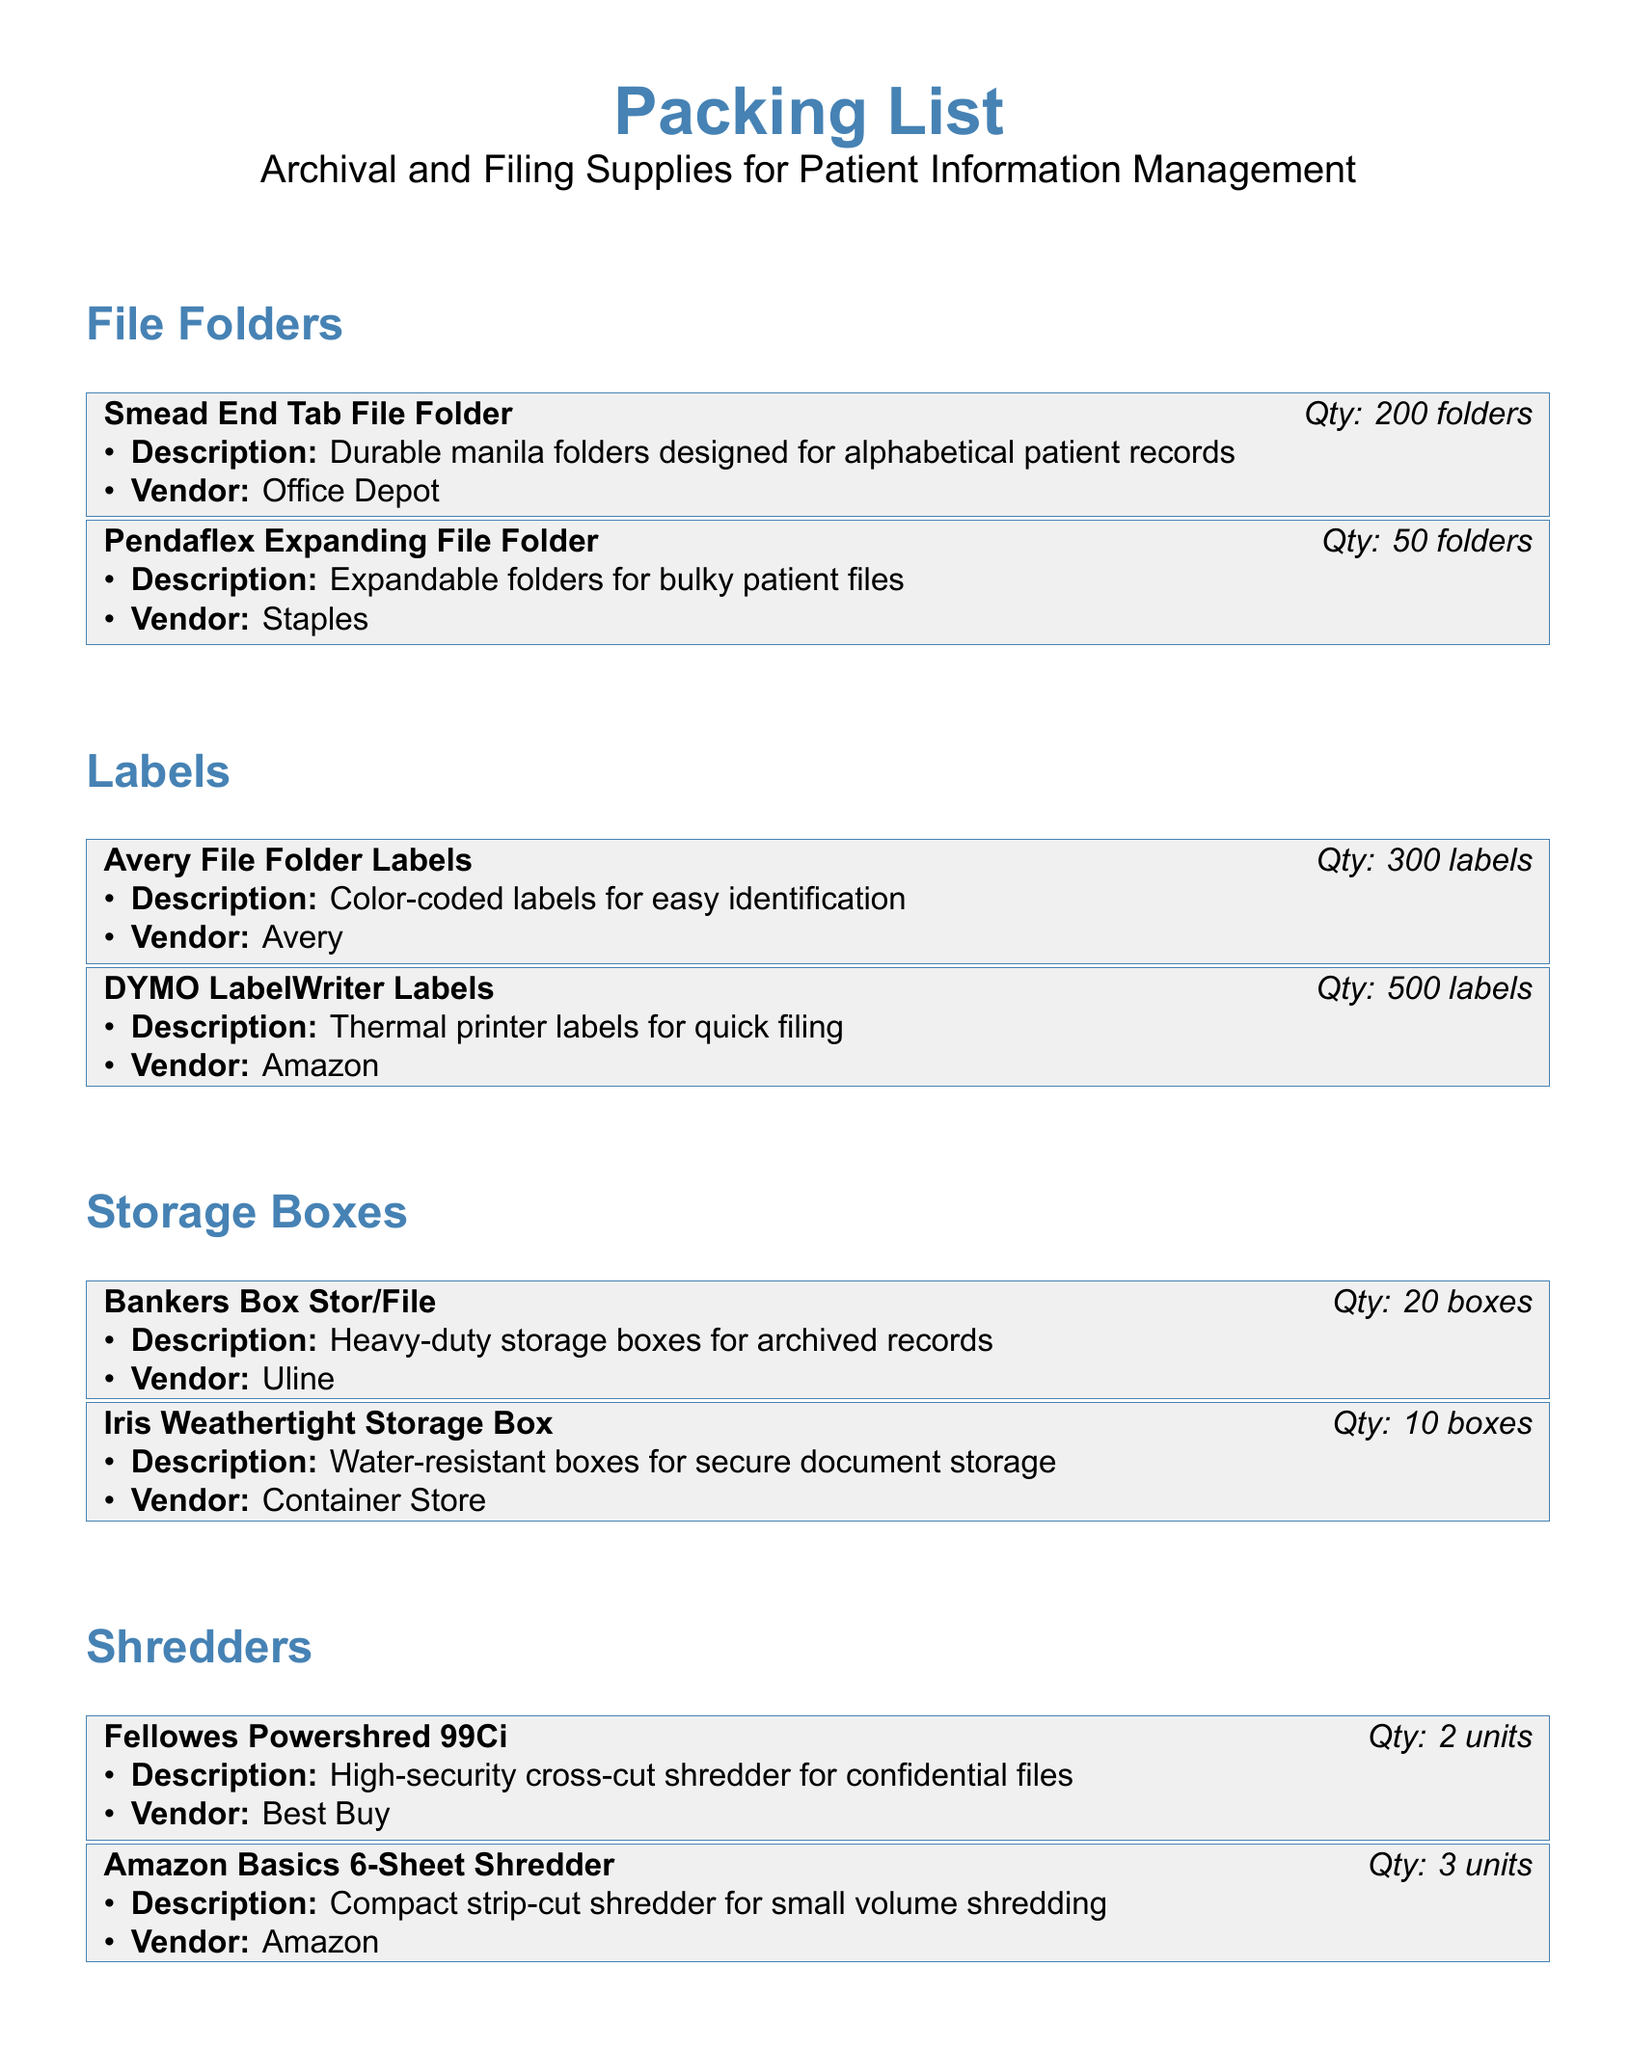What is the quantity of Smead End Tab File Folders? The document specifically lists that there are 200 folders of Smead End Tab File Folders.
Answer: 200 folders What type of shredder is the Fellowes Powershred 99Ci? The document describes this shredder as a high-security cross-cut shredder for confidential files.
Answer: High-security cross-cut How many boxes are included in the Bankers Box Stor/File? The inventory states that there are 20 boxes of Bankers Box Stor/File.
Answer: 20 boxes Which vendor supplies the Brother P-touch Label Maker? The document lists Brother as the vendor for the Brother P-touch Label Maker.
Answer: Brother What is the total number of labels provided by DYMO LabelWriter? The document mentions that there are 500 labels from DYMO LabelWriter.
Answer: 500 labels What is the purpose of Post-it Notes according to the document? The document states that Post-it Notes are for file indexing and temporary notes.
Answer: File indexing and temporary notes How many units of the Amazon Basics 6-Sheet Shredder are included? It is stated in the document that there are 3 units of the Amazon Basics 6-Sheet Shredder.
Answer: 3 units What is the description of the Iris Weathertight Storage Box? The document describes this box as water-resistant for secure document storage.
Answer: Water-resistant boxes for secure document storage What type of labels does Avery File Folder Labels feature? The document explains that these labels are color-coded for easy identification.
Answer: Color-coded labels for easy identification 